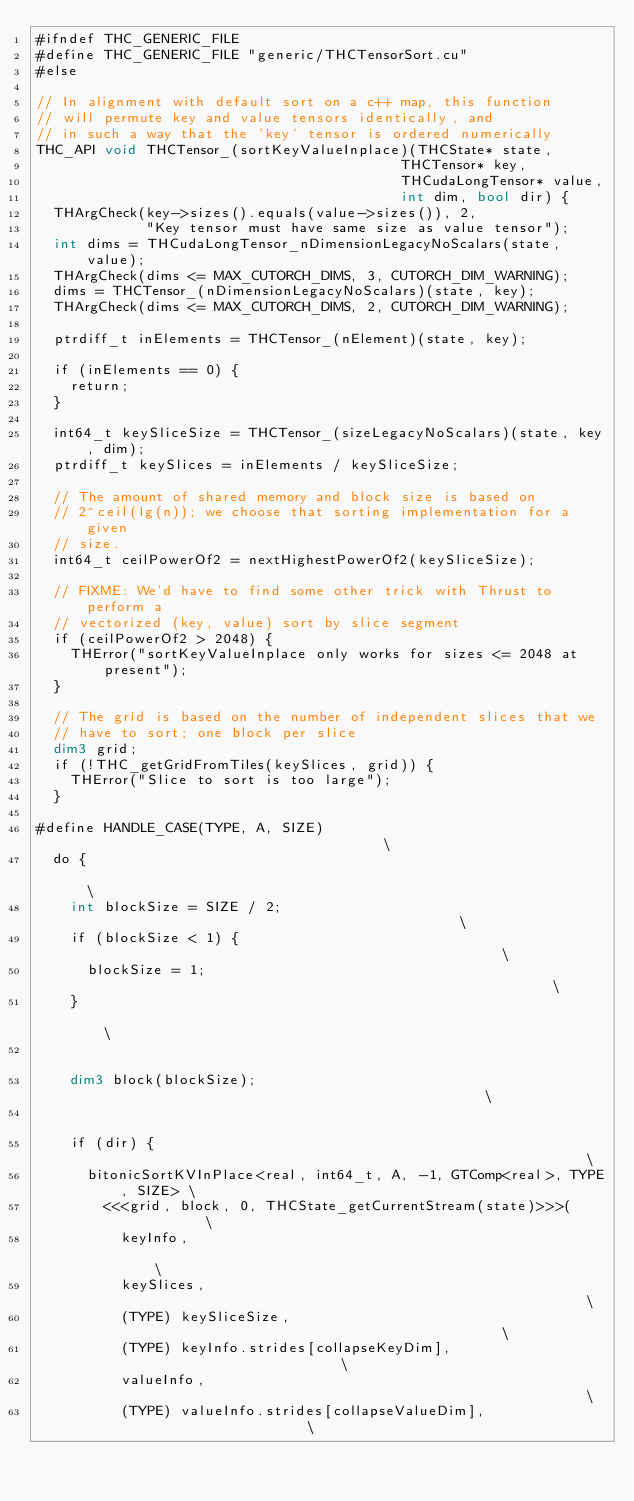Convert code to text. <code><loc_0><loc_0><loc_500><loc_500><_Cuda_>#ifndef THC_GENERIC_FILE
#define THC_GENERIC_FILE "generic/THCTensorSort.cu"
#else

// In alignment with default sort on a c++ map, this function
// will permute key and value tensors identically, and
// in such a way that the 'key' tensor is ordered numerically
THC_API void THCTensor_(sortKeyValueInplace)(THCState* state,
                                           THCTensor* key,
                                           THCudaLongTensor* value,
                                           int dim, bool dir) {
  THArgCheck(key->sizes().equals(value->sizes()), 2,
             "Key tensor must have same size as value tensor");
  int dims = THCudaLongTensor_nDimensionLegacyNoScalars(state, value);
  THArgCheck(dims <= MAX_CUTORCH_DIMS, 3, CUTORCH_DIM_WARNING);
  dims = THCTensor_(nDimensionLegacyNoScalars)(state, key);
  THArgCheck(dims <= MAX_CUTORCH_DIMS, 2, CUTORCH_DIM_WARNING);

  ptrdiff_t inElements = THCTensor_(nElement)(state, key);

  if (inElements == 0) {
    return;
  }

  int64_t keySliceSize = THCTensor_(sizeLegacyNoScalars)(state, key, dim);
  ptrdiff_t keySlices = inElements / keySliceSize;

  // The amount of shared memory and block size is based on
  // 2^ceil(lg(n)); we choose that sorting implementation for a given
  // size.
  int64_t ceilPowerOf2 = nextHighestPowerOf2(keySliceSize);

  // FIXME: We'd have to find some other trick with Thrust to perform a
  // vectorized (key, value) sort by slice segment
  if (ceilPowerOf2 > 2048) {
    THError("sortKeyValueInplace only works for sizes <= 2048 at present");
  }

  // The grid is based on the number of independent slices that we
  // have to sort; one block per slice
  dim3 grid;
  if (!THC_getGridFromTiles(keySlices, grid)) {
    THError("Slice to sort is too large");
  }

#define HANDLE_CASE(TYPE, A, SIZE)                                      \
  do {                                                                  \
    int blockSize = SIZE / 2;                                           \
    if (blockSize < 1) {                                                \
      blockSize = 1;                                                    \
    }                                                                   \
                                                                        \
    dim3 block(blockSize);                                              \
                                                                        \
    if (dir) {                                                          \
      bitonicSortKVInPlace<real, int64_t, A, -1, GTComp<real>, TYPE, SIZE> \
        <<<grid, block, 0, THCState_getCurrentStream(state)>>>(         \
          keyInfo,                                                      \
          keySlices,                                                    \
          (TYPE) keySliceSize,                                          \
          (TYPE) keyInfo.strides[collapseKeyDim],                       \
          valueInfo,                                                    \
          (TYPE) valueInfo.strides[collapseValueDim],                   \</code> 